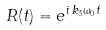Convert formula to latex. <formula><loc_0><loc_0><loc_500><loc_500>R ( t ) = e ^ { i \, k _ { 3 } \omega _ { 0 } t }</formula> 